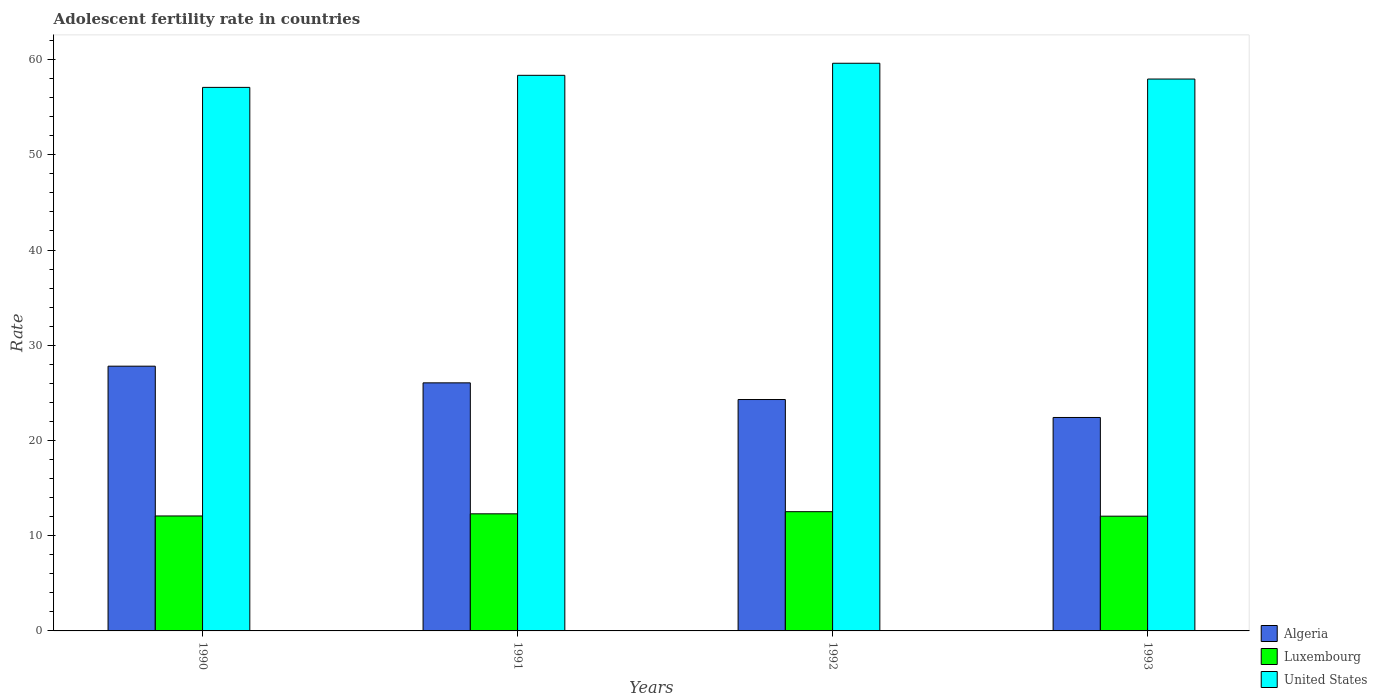How many bars are there on the 4th tick from the left?
Give a very brief answer. 3. In how many cases, is the number of bars for a given year not equal to the number of legend labels?
Offer a very short reply. 0. What is the adolescent fertility rate in United States in 1991?
Give a very brief answer. 58.35. Across all years, what is the maximum adolescent fertility rate in Luxembourg?
Ensure brevity in your answer.  12.52. Across all years, what is the minimum adolescent fertility rate in Luxembourg?
Your answer should be very brief. 12.05. In which year was the adolescent fertility rate in Algeria minimum?
Ensure brevity in your answer.  1993. What is the total adolescent fertility rate in United States in the graph?
Provide a short and direct response. 232.99. What is the difference between the adolescent fertility rate in Luxembourg in 1992 and that in 1993?
Provide a short and direct response. 0.47. What is the difference between the adolescent fertility rate in Algeria in 1992 and the adolescent fertility rate in Luxembourg in 1991?
Provide a short and direct response. 12. What is the average adolescent fertility rate in Luxembourg per year?
Make the answer very short. 12.24. In the year 1993, what is the difference between the adolescent fertility rate in United States and adolescent fertility rate in Luxembourg?
Offer a very short reply. 45.91. What is the ratio of the adolescent fertility rate in United States in 1990 to that in 1992?
Keep it short and to the point. 0.96. Is the adolescent fertility rate in United States in 1991 less than that in 1992?
Ensure brevity in your answer.  Yes. What is the difference between the highest and the second highest adolescent fertility rate in United States?
Your answer should be very brief. 1.27. What is the difference between the highest and the lowest adolescent fertility rate in Luxembourg?
Offer a very short reply. 0.47. In how many years, is the adolescent fertility rate in Luxembourg greater than the average adolescent fertility rate in Luxembourg taken over all years?
Make the answer very short. 2. Is the sum of the adolescent fertility rate in Luxembourg in 1991 and 1992 greater than the maximum adolescent fertility rate in Algeria across all years?
Make the answer very short. No. What does the 3rd bar from the left in 1991 represents?
Ensure brevity in your answer.  United States. Is it the case that in every year, the sum of the adolescent fertility rate in United States and adolescent fertility rate in Algeria is greater than the adolescent fertility rate in Luxembourg?
Your answer should be very brief. Yes. Are the values on the major ticks of Y-axis written in scientific E-notation?
Offer a very short reply. No. Does the graph contain any zero values?
Give a very brief answer. No. How many legend labels are there?
Offer a terse response. 3. What is the title of the graph?
Keep it short and to the point. Adolescent fertility rate in countries. Does "Iran" appear as one of the legend labels in the graph?
Provide a short and direct response. No. What is the label or title of the Y-axis?
Give a very brief answer. Rate. What is the Rate in Algeria in 1990?
Provide a succinct answer. 27.8. What is the Rate of Luxembourg in 1990?
Your response must be concise. 12.07. What is the Rate of United States in 1990?
Give a very brief answer. 57.08. What is the Rate of Algeria in 1991?
Give a very brief answer. 26.05. What is the Rate in Luxembourg in 1991?
Offer a very short reply. 12.3. What is the Rate of United States in 1991?
Provide a short and direct response. 58.35. What is the Rate in Algeria in 1992?
Your answer should be compact. 24.3. What is the Rate in Luxembourg in 1992?
Make the answer very short. 12.52. What is the Rate in United States in 1992?
Provide a succinct answer. 59.61. What is the Rate of Algeria in 1993?
Provide a short and direct response. 22.41. What is the Rate in Luxembourg in 1993?
Give a very brief answer. 12.05. What is the Rate of United States in 1993?
Your answer should be compact. 57.96. Across all years, what is the maximum Rate in Algeria?
Offer a very short reply. 27.8. Across all years, what is the maximum Rate of Luxembourg?
Your response must be concise. 12.52. Across all years, what is the maximum Rate of United States?
Provide a short and direct response. 59.61. Across all years, what is the minimum Rate in Algeria?
Offer a very short reply. 22.41. Across all years, what is the minimum Rate in Luxembourg?
Make the answer very short. 12.05. Across all years, what is the minimum Rate in United States?
Offer a very short reply. 57.08. What is the total Rate in Algeria in the graph?
Make the answer very short. 100.57. What is the total Rate in Luxembourg in the graph?
Provide a succinct answer. 48.94. What is the total Rate of United States in the graph?
Offer a very short reply. 232.99. What is the difference between the Rate in Algeria in 1990 and that in 1991?
Your answer should be compact. 1.75. What is the difference between the Rate of Luxembourg in 1990 and that in 1991?
Keep it short and to the point. -0.22. What is the difference between the Rate of United States in 1990 and that in 1991?
Make the answer very short. -1.27. What is the difference between the Rate in Algeria in 1990 and that in 1992?
Your response must be concise. 3.5. What is the difference between the Rate in Luxembourg in 1990 and that in 1992?
Give a very brief answer. -0.45. What is the difference between the Rate in United States in 1990 and that in 1992?
Offer a terse response. -2.53. What is the difference between the Rate of Algeria in 1990 and that in 1993?
Offer a terse response. 5.39. What is the difference between the Rate in Luxembourg in 1990 and that in 1993?
Provide a short and direct response. 0.02. What is the difference between the Rate in United States in 1990 and that in 1993?
Your answer should be compact. -0.88. What is the difference between the Rate of Algeria in 1991 and that in 1992?
Offer a terse response. 1.75. What is the difference between the Rate of Luxembourg in 1991 and that in 1992?
Ensure brevity in your answer.  -0.22. What is the difference between the Rate of United States in 1991 and that in 1992?
Your answer should be very brief. -1.27. What is the difference between the Rate of Algeria in 1991 and that in 1993?
Provide a short and direct response. 3.64. What is the difference between the Rate of Luxembourg in 1991 and that in 1993?
Make the answer very short. 0.25. What is the difference between the Rate of United States in 1991 and that in 1993?
Give a very brief answer. 0.39. What is the difference between the Rate of Algeria in 1992 and that in 1993?
Make the answer very short. 1.89. What is the difference between the Rate of Luxembourg in 1992 and that in 1993?
Offer a very short reply. 0.47. What is the difference between the Rate in United States in 1992 and that in 1993?
Keep it short and to the point. 1.66. What is the difference between the Rate of Algeria in 1990 and the Rate of Luxembourg in 1991?
Your response must be concise. 15.5. What is the difference between the Rate in Algeria in 1990 and the Rate in United States in 1991?
Provide a succinct answer. -30.54. What is the difference between the Rate in Luxembourg in 1990 and the Rate in United States in 1991?
Provide a short and direct response. -46.27. What is the difference between the Rate in Algeria in 1990 and the Rate in Luxembourg in 1992?
Keep it short and to the point. 15.28. What is the difference between the Rate of Algeria in 1990 and the Rate of United States in 1992?
Provide a succinct answer. -31.81. What is the difference between the Rate of Luxembourg in 1990 and the Rate of United States in 1992?
Your response must be concise. -47.54. What is the difference between the Rate of Algeria in 1990 and the Rate of Luxembourg in 1993?
Your answer should be very brief. 15.75. What is the difference between the Rate in Algeria in 1990 and the Rate in United States in 1993?
Offer a very short reply. -30.15. What is the difference between the Rate of Luxembourg in 1990 and the Rate of United States in 1993?
Offer a very short reply. -45.88. What is the difference between the Rate of Algeria in 1991 and the Rate of Luxembourg in 1992?
Your answer should be very brief. 13.53. What is the difference between the Rate in Algeria in 1991 and the Rate in United States in 1992?
Provide a short and direct response. -33.56. What is the difference between the Rate in Luxembourg in 1991 and the Rate in United States in 1992?
Your answer should be compact. -47.31. What is the difference between the Rate in Algeria in 1991 and the Rate in Luxembourg in 1993?
Give a very brief answer. 14. What is the difference between the Rate in Algeria in 1991 and the Rate in United States in 1993?
Provide a succinct answer. -31.91. What is the difference between the Rate in Luxembourg in 1991 and the Rate in United States in 1993?
Provide a short and direct response. -45.66. What is the difference between the Rate of Algeria in 1992 and the Rate of Luxembourg in 1993?
Your answer should be compact. 12.25. What is the difference between the Rate in Algeria in 1992 and the Rate in United States in 1993?
Provide a succinct answer. -33.66. What is the difference between the Rate of Luxembourg in 1992 and the Rate of United States in 1993?
Your answer should be very brief. -45.43. What is the average Rate in Algeria per year?
Your answer should be compact. 25.14. What is the average Rate of Luxembourg per year?
Your answer should be compact. 12.24. What is the average Rate of United States per year?
Keep it short and to the point. 58.25. In the year 1990, what is the difference between the Rate of Algeria and Rate of Luxembourg?
Your answer should be very brief. 15.73. In the year 1990, what is the difference between the Rate of Algeria and Rate of United States?
Ensure brevity in your answer.  -29.28. In the year 1990, what is the difference between the Rate of Luxembourg and Rate of United States?
Your answer should be very brief. -45.01. In the year 1991, what is the difference between the Rate in Algeria and Rate in Luxembourg?
Offer a very short reply. 13.75. In the year 1991, what is the difference between the Rate in Algeria and Rate in United States?
Your answer should be very brief. -32.29. In the year 1991, what is the difference between the Rate of Luxembourg and Rate of United States?
Your response must be concise. -46.05. In the year 1992, what is the difference between the Rate in Algeria and Rate in Luxembourg?
Offer a very short reply. 11.78. In the year 1992, what is the difference between the Rate in Algeria and Rate in United States?
Make the answer very short. -35.31. In the year 1992, what is the difference between the Rate in Luxembourg and Rate in United States?
Your response must be concise. -47.09. In the year 1993, what is the difference between the Rate in Algeria and Rate in Luxembourg?
Make the answer very short. 10.36. In the year 1993, what is the difference between the Rate of Algeria and Rate of United States?
Provide a succinct answer. -35.54. In the year 1993, what is the difference between the Rate in Luxembourg and Rate in United States?
Make the answer very short. -45.91. What is the ratio of the Rate in Algeria in 1990 to that in 1991?
Offer a very short reply. 1.07. What is the ratio of the Rate of Luxembourg in 1990 to that in 1991?
Provide a short and direct response. 0.98. What is the ratio of the Rate in United States in 1990 to that in 1991?
Your answer should be very brief. 0.98. What is the ratio of the Rate of Algeria in 1990 to that in 1992?
Offer a terse response. 1.14. What is the ratio of the Rate in Luxembourg in 1990 to that in 1992?
Your response must be concise. 0.96. What is the ratio of the Rate in United States in 1990 to that in 1992?
Offer a very short reply. 0.96. What is the ratio of the Rate in Algeria in 1990 to that in 1993?
Provide a succinct answer. 1.24. What is the ratio of the Rate of Luxembourg in 1990 to that in 1993?
Keep it short and to the point. 1. What is the ratio of the Rate in United States in 1990 to that in 1993?
Provide a succinct answer. 0.98. What is the ratio of the Rate in Algeria in 1991 to that in 1992?
Ensure brevity in your answer.  1.07. What is the ratio of the Rate in Luxembourg in 1991 to that in 1992?
Your response must be concise. 0.98. What is the ratio of the Rate of United States in 1991 to that in 1992?
Provide a succinct answer. 0.98. What is the ratio of the Rate of Algeria in 1991 to that in 1993?
Provide a succinct answer. 1.16. What is the ratio of the Rate in Luxembourg in 1991 to that in 1993?
Your answer should be very brief. 1.02. What is the ratio of the Rate of Algeria in 1992 to that in 1993?
Ensure brevity in your answer.  1.08. What is the ratio of the Rate of Luxembourg in 1992 to that in 1993?
Keep it short and to the point. 1.04. What is the ratio of the Rate of United States in 1992 to that in 1993?
Give a very brief answer. 1.03. What is the difference between the highest and the second highest Rate in Algeria?
Offer a terse response. 1.75. What is the difference between the highest and the second highest Rate of Luxembourg?
Offer a very short reply. 0.22. What is the difference between the highest and the second highest Rate in United States?
Your response must be concise. 1.27. What is the difference between the highest and the lowest Rate of Algeria?
Give a very brief answer. 5.39. What is the difference between the highest and the lowest Rate of Luxembourg?
Offer a very short reply. 0.47. What is the difference between the highest and the lowest Rate of United States?
Ensure brevity in your answer.  2.53. 